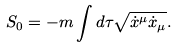<formula> <loc_0><loc_0><loc_500><loc_500>S _ { 0 } = - m \int d \tau \sqrt { \dot { x } ^ { \mu } \dot { x } _ { \mu } } .</formula> 